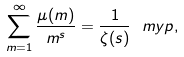Convert formula to latex. <formula><loc_0><loc_0><loc_500><loc_500>\sum _ { m = 1 } ^ { \infty } \frac { \mu ( m ) } { m ^ { s } } = \frac { 1 } { \zeta ( s ) } \ m y p ,</formula> 